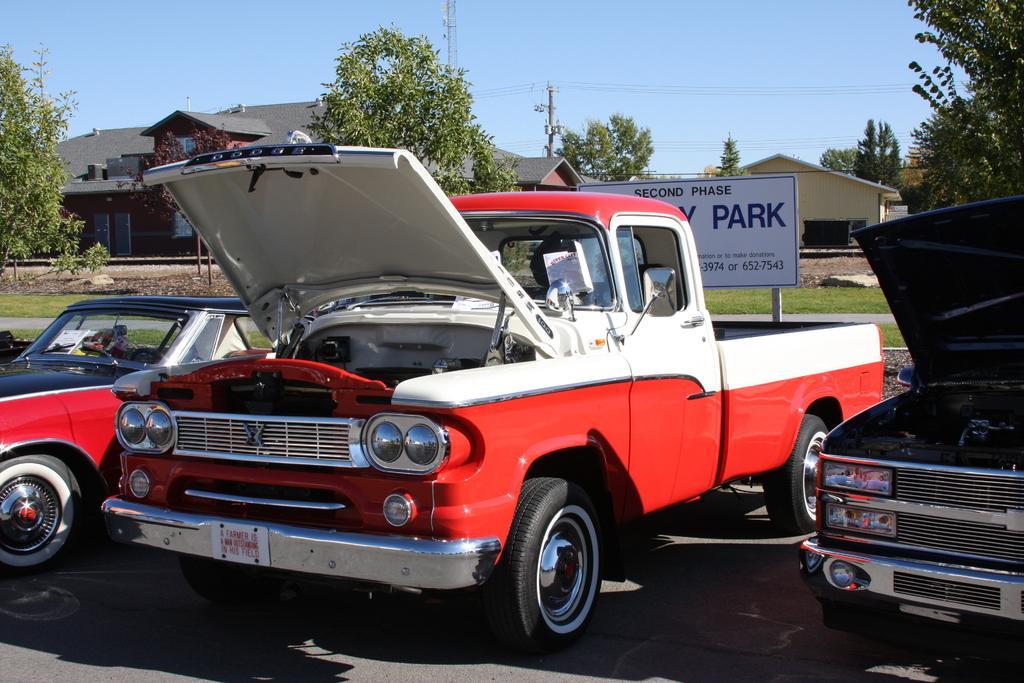Describe this image in one or two sentences. In this picture we can see vehicles on the road, board, pole and grass. In the background of the image we can see trees, houses and sky. 